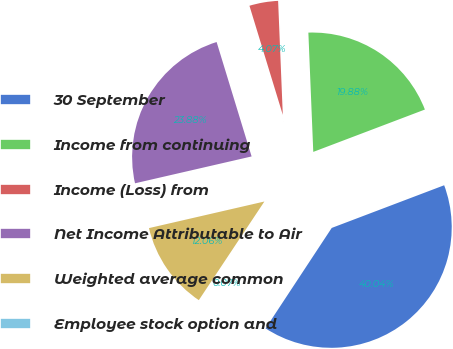<chart> <loc_0><loc_0><loc_500><loc_500><pie_chart><fcel>30 September<fcel>Income from continuing<fcel>Income (Loss) from<fcel>Net Income Attributable to Air<fcel>Weighted average common<fcel>Employee stock option and<nl><fcel>40.04%<fcel>19.88%<fcel>4.07%<fcel>23.88%<fcel>12.06%<fcel>0.07%<nl></chart> 